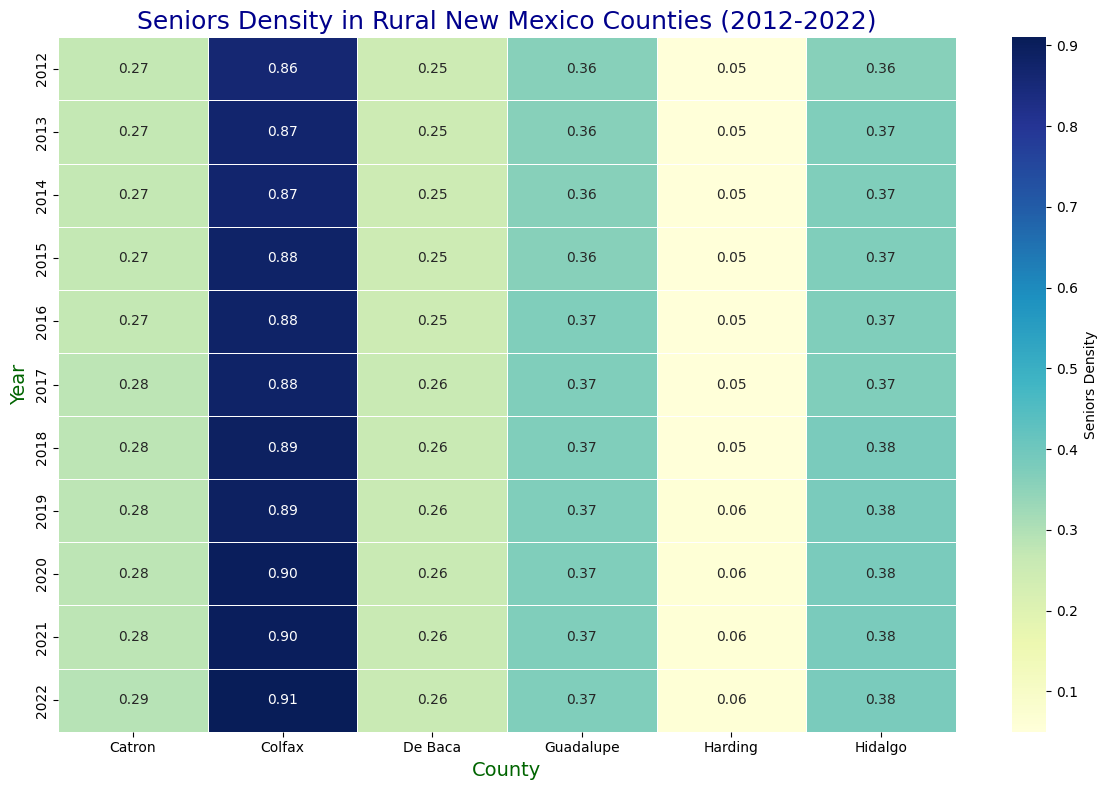What is the senior density in Catron county in 2022? The color shade and annotation for Catron County in 2022 shows a value around 0.29.
Answer: 0.29 How did the senior density change in Catron county from 2012 to 2022? By comparing the annotated values for Catron County from 2012 (0.27) to 2022 (0.29), the change can be calculated.
Answer: Increased by 0.02 Which county had the highest senior density in 2022? Looking across the counties at the 2022 row, the highest number annotated is 0.91 in Colfax County.
Answer: Colfax Did the senior density in De Baca county ever reach 0.26 between 2012 and 2022? Reviewing the annotated values for De Baca, the senior density reached 0.26 from 2017 onwards.
Answer: Yes What is the average senior density in Colfax county over the last five years? Annotated values for Colfax from 2018 to 2022 are 0.89, 0.89, 0.90, 0.90, 0.91. Summing them up gives 4.49, and the average is 4.49/5.
Answer: 0.898 Compare the senior density of Hidalgo and Guadalupe counties in 2022. Which one was higher? For 2022, Hidalgo is annotated as 0.38 and Guadalupe as 0.37. Hidalgo's density is higher.
Answer: Hidalgo What is the trend in senior density in the smallest population county (Harding) over the last decade? The annotated values for Harding show a consistent increase from 0.05 in 2012 to 0.06 in 2022.
Answer: Increasing Which year did Colfax county first reach a senior density of 0.90? Annotated values for Colfax show it reached 0.90 in 2020.
Answer: 2020 Is the senior density in Catron county in 2022 more or less than twice the density of seniors in Harding county? In 2022, Catron's senior density is 0.29, and Harding's is 0.06. 0.29 is less than twice 0.06 (0.12).
Answer: Less 